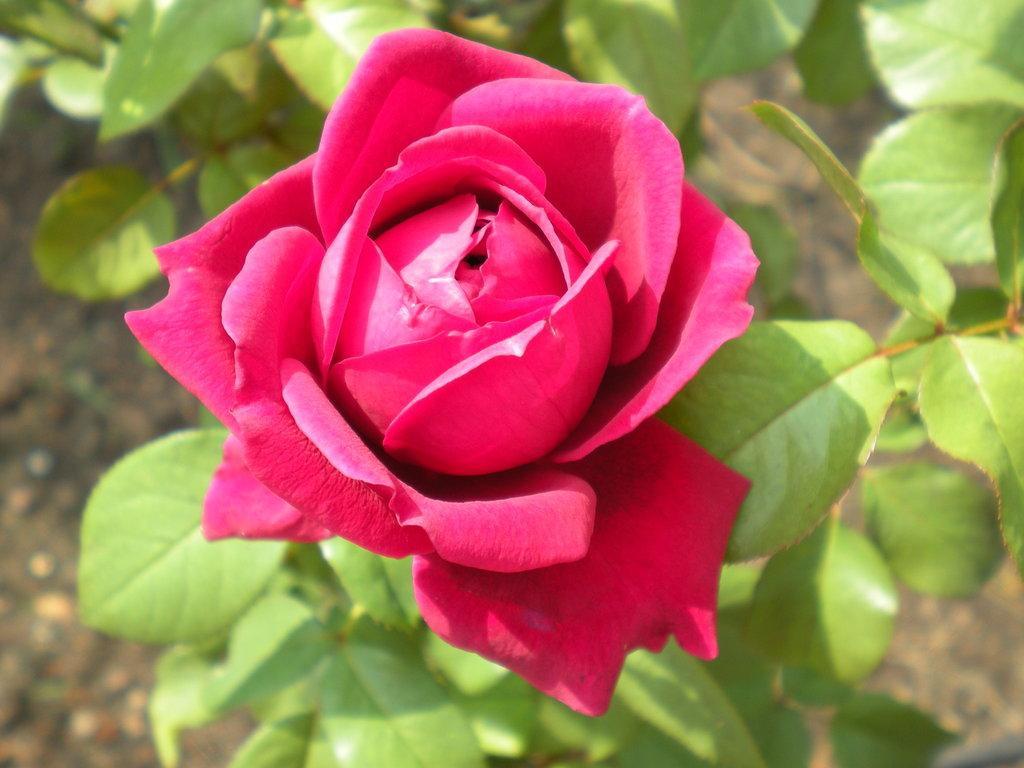Please provide a concise description of this image. In this image we can see a flower to the plant. 